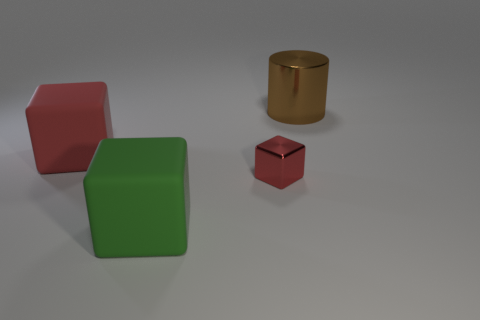What number of blue things are either small metal cubes or big metal objects?
Your answer should be compact. 0. Do the red metallic thing and the big brown thing have the same shape?
Your answer should be very brief. No. Is there a small cube in front of the thing that is in front of the small red metallic object?
Your answer should be compact. No. Are there an equal number of large green cubes behind the red rubber object and small metallic objects?
Ensure brevity in your answer.  No. What number of other objects are the same size as the metallic cylinder?
Provide a short and direct response. 2. Does the big thing on the right side of the small red thing have the same material as the red block that is on the right side of the big red matte thing?
Your answer should be compact. Yes. What is the size of the metal object to the left of the shiny cylinder right of the big red rubber object?
Provide a succinct answer. Small. Is there a metal cylinder that has the same color as the small metallic block?
Offer a very short reply. No. There is a big matte block that is in front of the big red matte object; is its color the same as the matte block left of the big green cube?
Your answer should be compact. No. The red metallic thing has what shape?
Your answer should be very brief. Cube. 